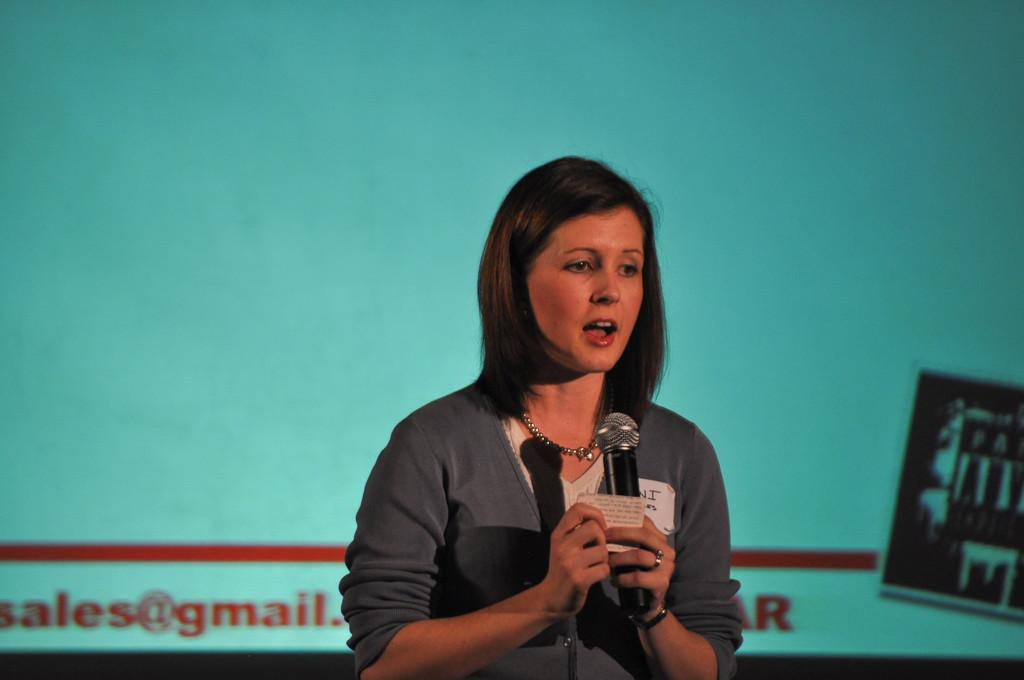Who is the main subject in the image? There is a woman in the image. What is the woman doing in the image? The woman is standing and holding a microphone in her hand. What might the woman be doing with the microphone? The woman may be talking or giving a speech. What can be seen in the background of the image? There is a screen with a display in the background of the image. What type of cake is being shared between the woman and her friend in the image? There is no cake or friend present in the image. How many sheep can be seen in the background of the image? There are no sheep visible in the image; only a screen with a display is present in the background. 